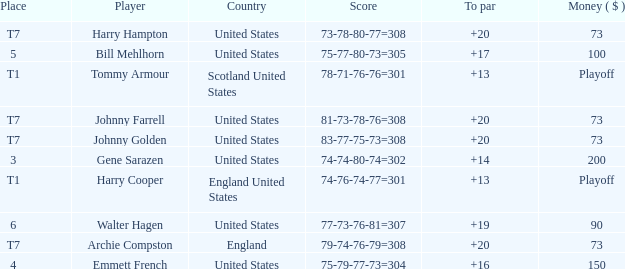Which country has a to par less than 19 and a score of 75-79-77-73=304? United States. 